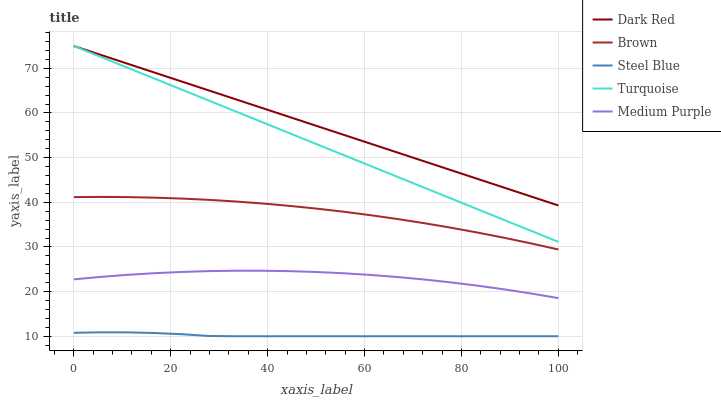Does Steel Blue have the minimum area under the curve?
Answer yes or no. Yes. Does Dark Red have the maximum area under the curve?
Answer yes or no. Yes. Does Turquoise have the minimum area under the curve?
Answer yes or no. No. Does Turquoise have the maximum area under the curve?
Answer yes or no. No. Is Dark Red the smoothest?
Answer yes or no. Yes. Is Medium Purple the roughest?
Answer yes or no. Yes. Is Turquoise the smoothest?
Answer yes or no. No. Is Turquoise the roughest?
Answer yes or no. No. Does Turquoise have the lowest value?
Answer yes or no. No. Does Turquoise have the highest value?
Answer yes or no. Yes. Does Steel Blue have the highest value?
Answer yes or no. No. Is Steel Blue less than Medium Purple?
Answer yes or no. Yes. Is Medium Purple greater than Steel Blue?
Answer yes or no. Yes. Does Dark Red intersect Turquoise?
Answer yes or no. Yes. Is Dark Red less than Turquoise?
Answer yes or no. No. Is Dark Red greater than Turquoise?
Answer yes or no. No. Does Steel Blue intersect Medium Purple?
Answer yes or no. No. 